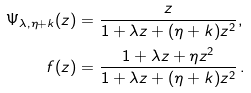<formula> <loc_0><loc_0><loc_500><loc_500>\Psi _ { \lambda , \eta + k } ( z ) & = \frac { z } { 1 + \lambda z + ( \eta + k ) z ^ { 2 } } , \\ f ( z ) & = \frac { 1 + \lambda z + \eta z ^ { 2 } } { 1 + \lambda z + ( \eta + k ) z ^ { 2 } } \, .</formula> 